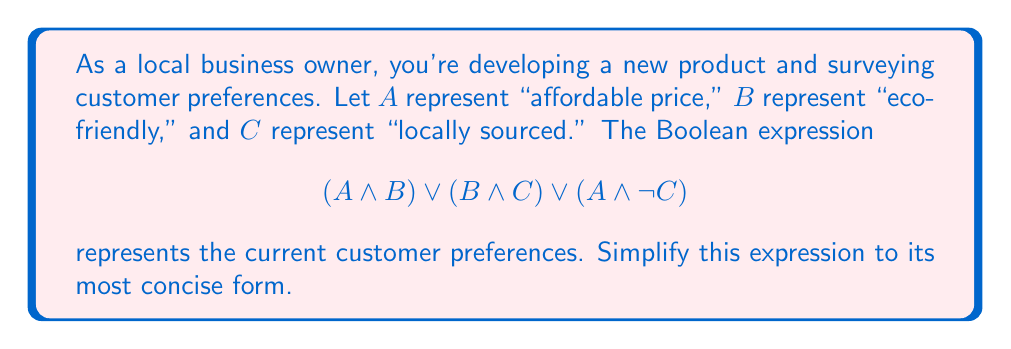Provide a solution to this math problem. Let's simplify this Boolean expression step-by-step:

1) First, let's apply the distributive law to the first two terms:
   $$(A \land B) \lor (B \land C) = B \land (A \lor C)$$

2) Now our expression looks like:
   $$B \land (A \lor C) \lor (A \land \lnot C)$$

3) Let's focus on the last term $(A \land \lnot C)$. We can use the absorption law with the $(A \lor C)$ term:
   $$(A \lor C) \lor (A \land \lnot C) = A \lor C$$

4) Substituting this back into our expression:
   $$B \land (A \lor C) \lor A$$

5) Now we can use the distributive law again:
   $$(B \land A) \lor (B \land C) \lor A$$

6) Rearranging terms (commutativity):
   $$A \lor (B \land A) \lor (B \land C)$$

7) We can now use the absorption law to simplify further:
   $$A \lor (B \land C)$$

This is the most simplified form of the original expression.
Answer: $$A \lor (B \land C)$$ 